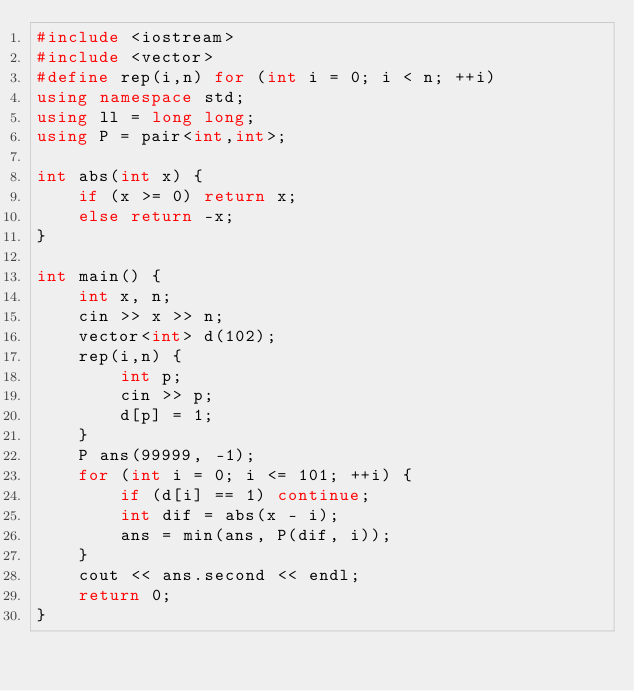Convert code to text. <code><loc_0><loc_0><loc_500><loc_500><_C++_>#include <iostream>
#include <vector>
#define rep(i,n) for (int i = 0; i < n; ++i)
using namespace std;
using ll = long long;
using P = pair<int,int>;

int abs(int x) {
    if (x >= 0) return x;
    else return -x;
}

int main() {
    int x, n;
    cin >> x >> n;
    vector<int> d(102);
    rep(i,n) {
        int p;
        cin >> p;
        d[p] = 1;
    }
    P ans(99999, -1);
    for (int i = 0; i <= 101; ++i) {
        if (d[i] == 1) continue;
        int dif = abs(x - i);
        ans = min(ans, P(dif, i));
    }
    cout << ans.second << endl;
    return 0;
}</code> 